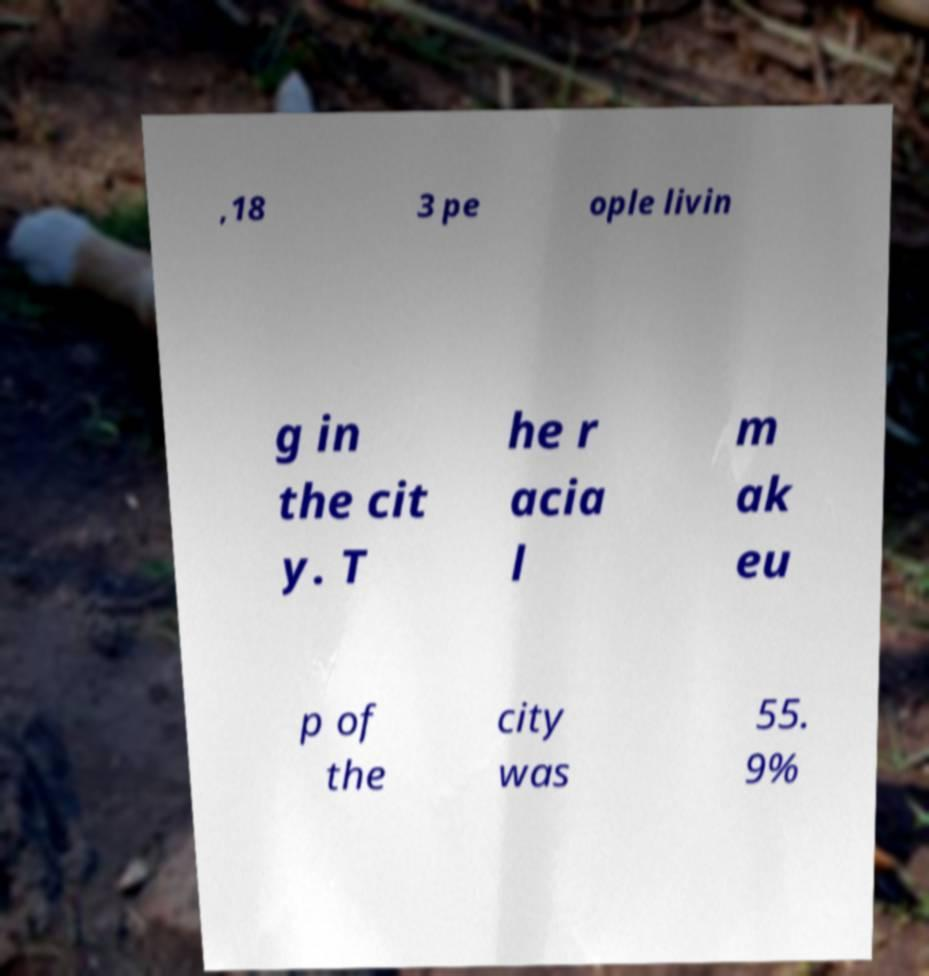Could you extract and type out the text from this image? ,18 3 pe ople livin g in the cit y. T he r acia l m ak eu p of the city was 55. 9% 